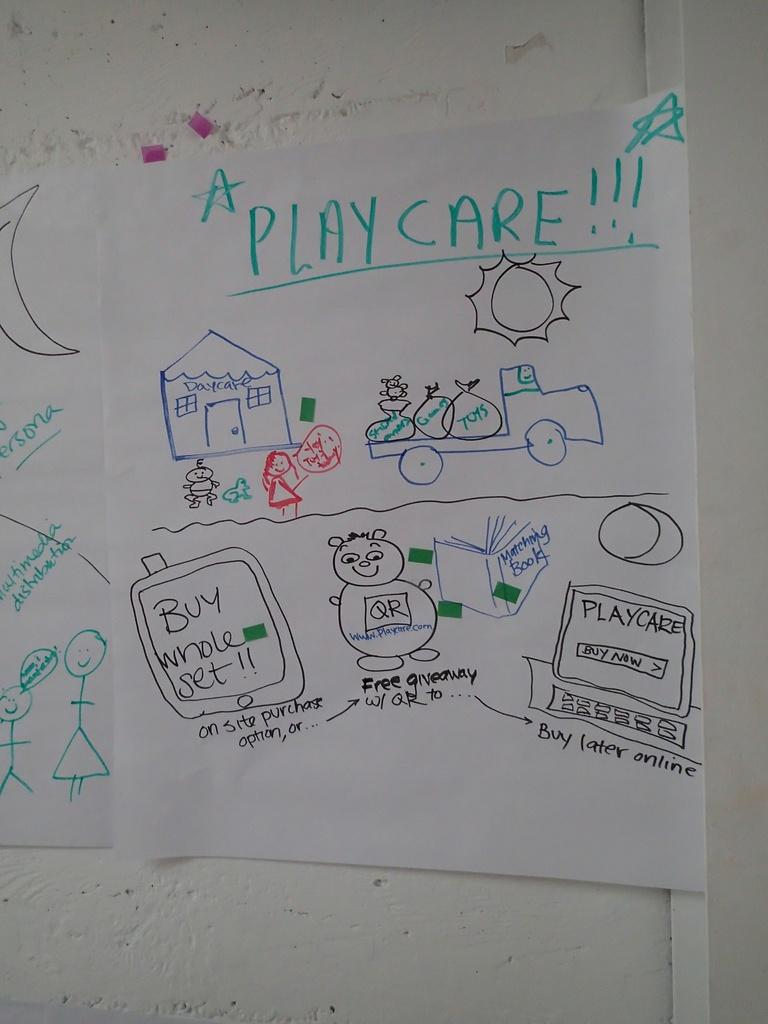What is the main subject of the image? The main subject of the image is a white color chart. Where is the color chart located in the image? The color chart is attached to the wall. What can be seen on the color chart? Something is written on the chart, and the writing is in black, green, and blue colors. What color is the wall in the image? The wall is white. How does the beggar feel about the planes in the image? There is no beggar or planes present in the image, so this question cannot be answered. 